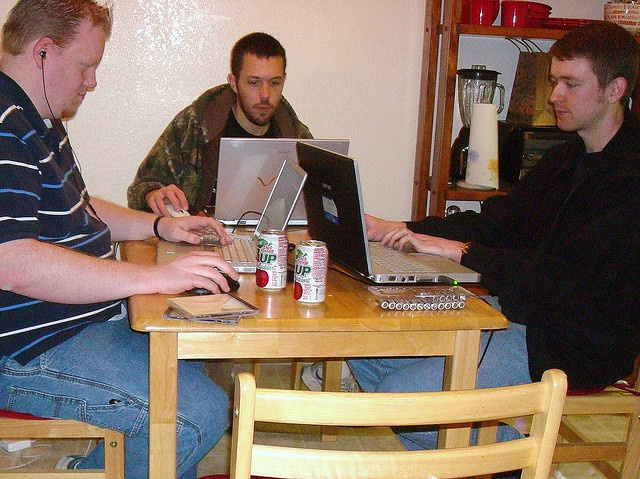Describe the objects in this image and their specific colors. I can see people in tan, black, lightpink, gray, and brown tones, dining table in tan, black, darkgray, and gray tones, people in tan, black, brown, maroon, and gray tones, chair in tan, khaki, lightyellow, and gray tones, and people in tan, black, maroon, and brown tones in this image. 